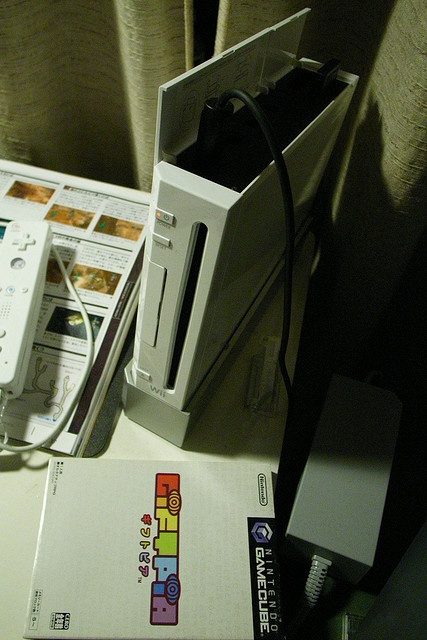Describe the objects in this image and their specific colors. I can see book in black, darkgray, and beige tones and remote in black, beige, and gray tones in this image. 